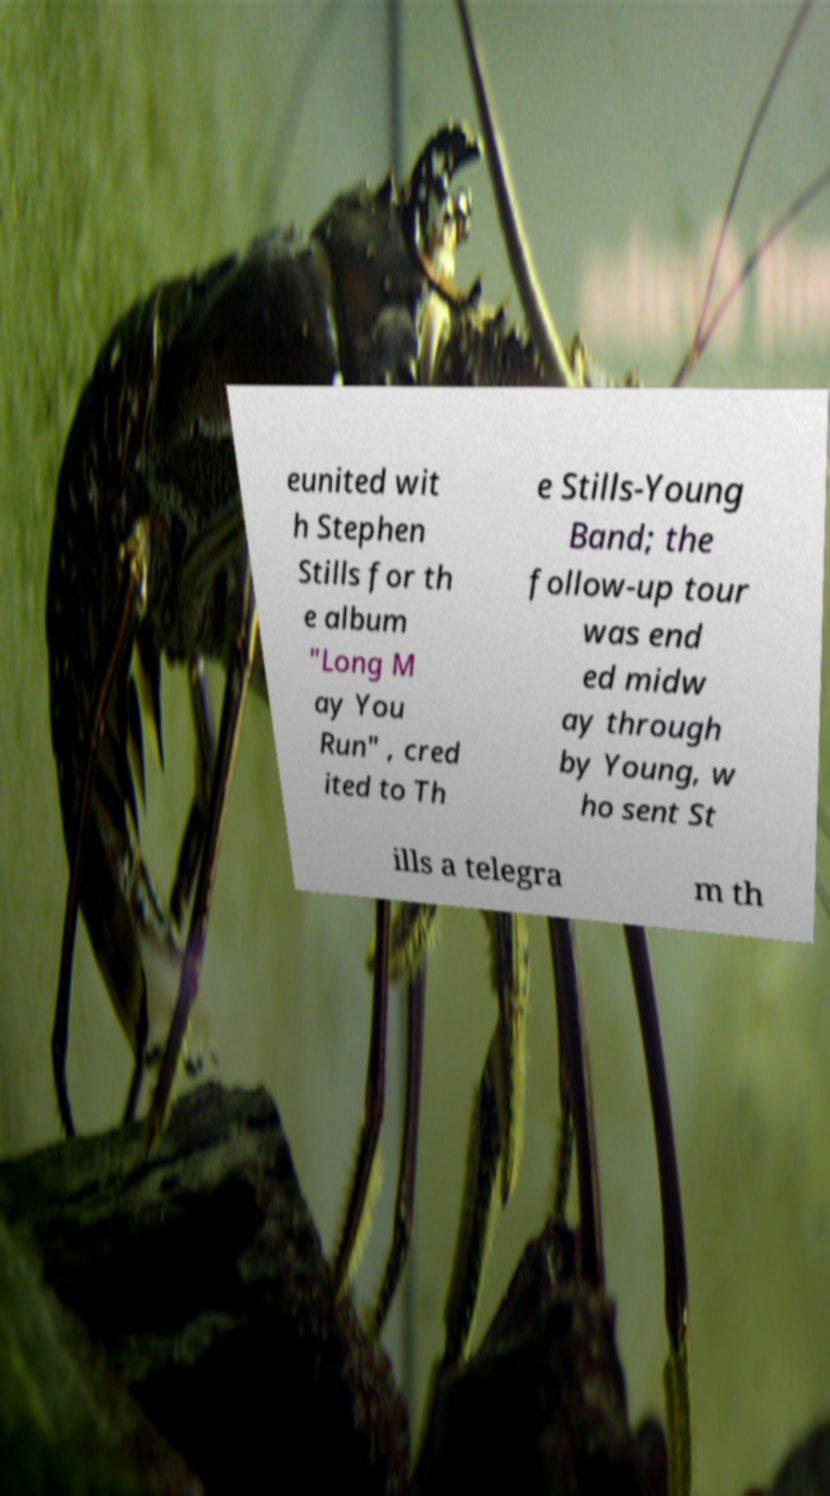What messages or text are displayed in this image? I need them in a readable, typed format. eunited wit h Stephen Stills for th e album "Long M ay You Run" , cred ited to Th e Stills-Young Band; the follow-up tour was end ed midw ay through by Young, w ho sent St ills a telegra m th 